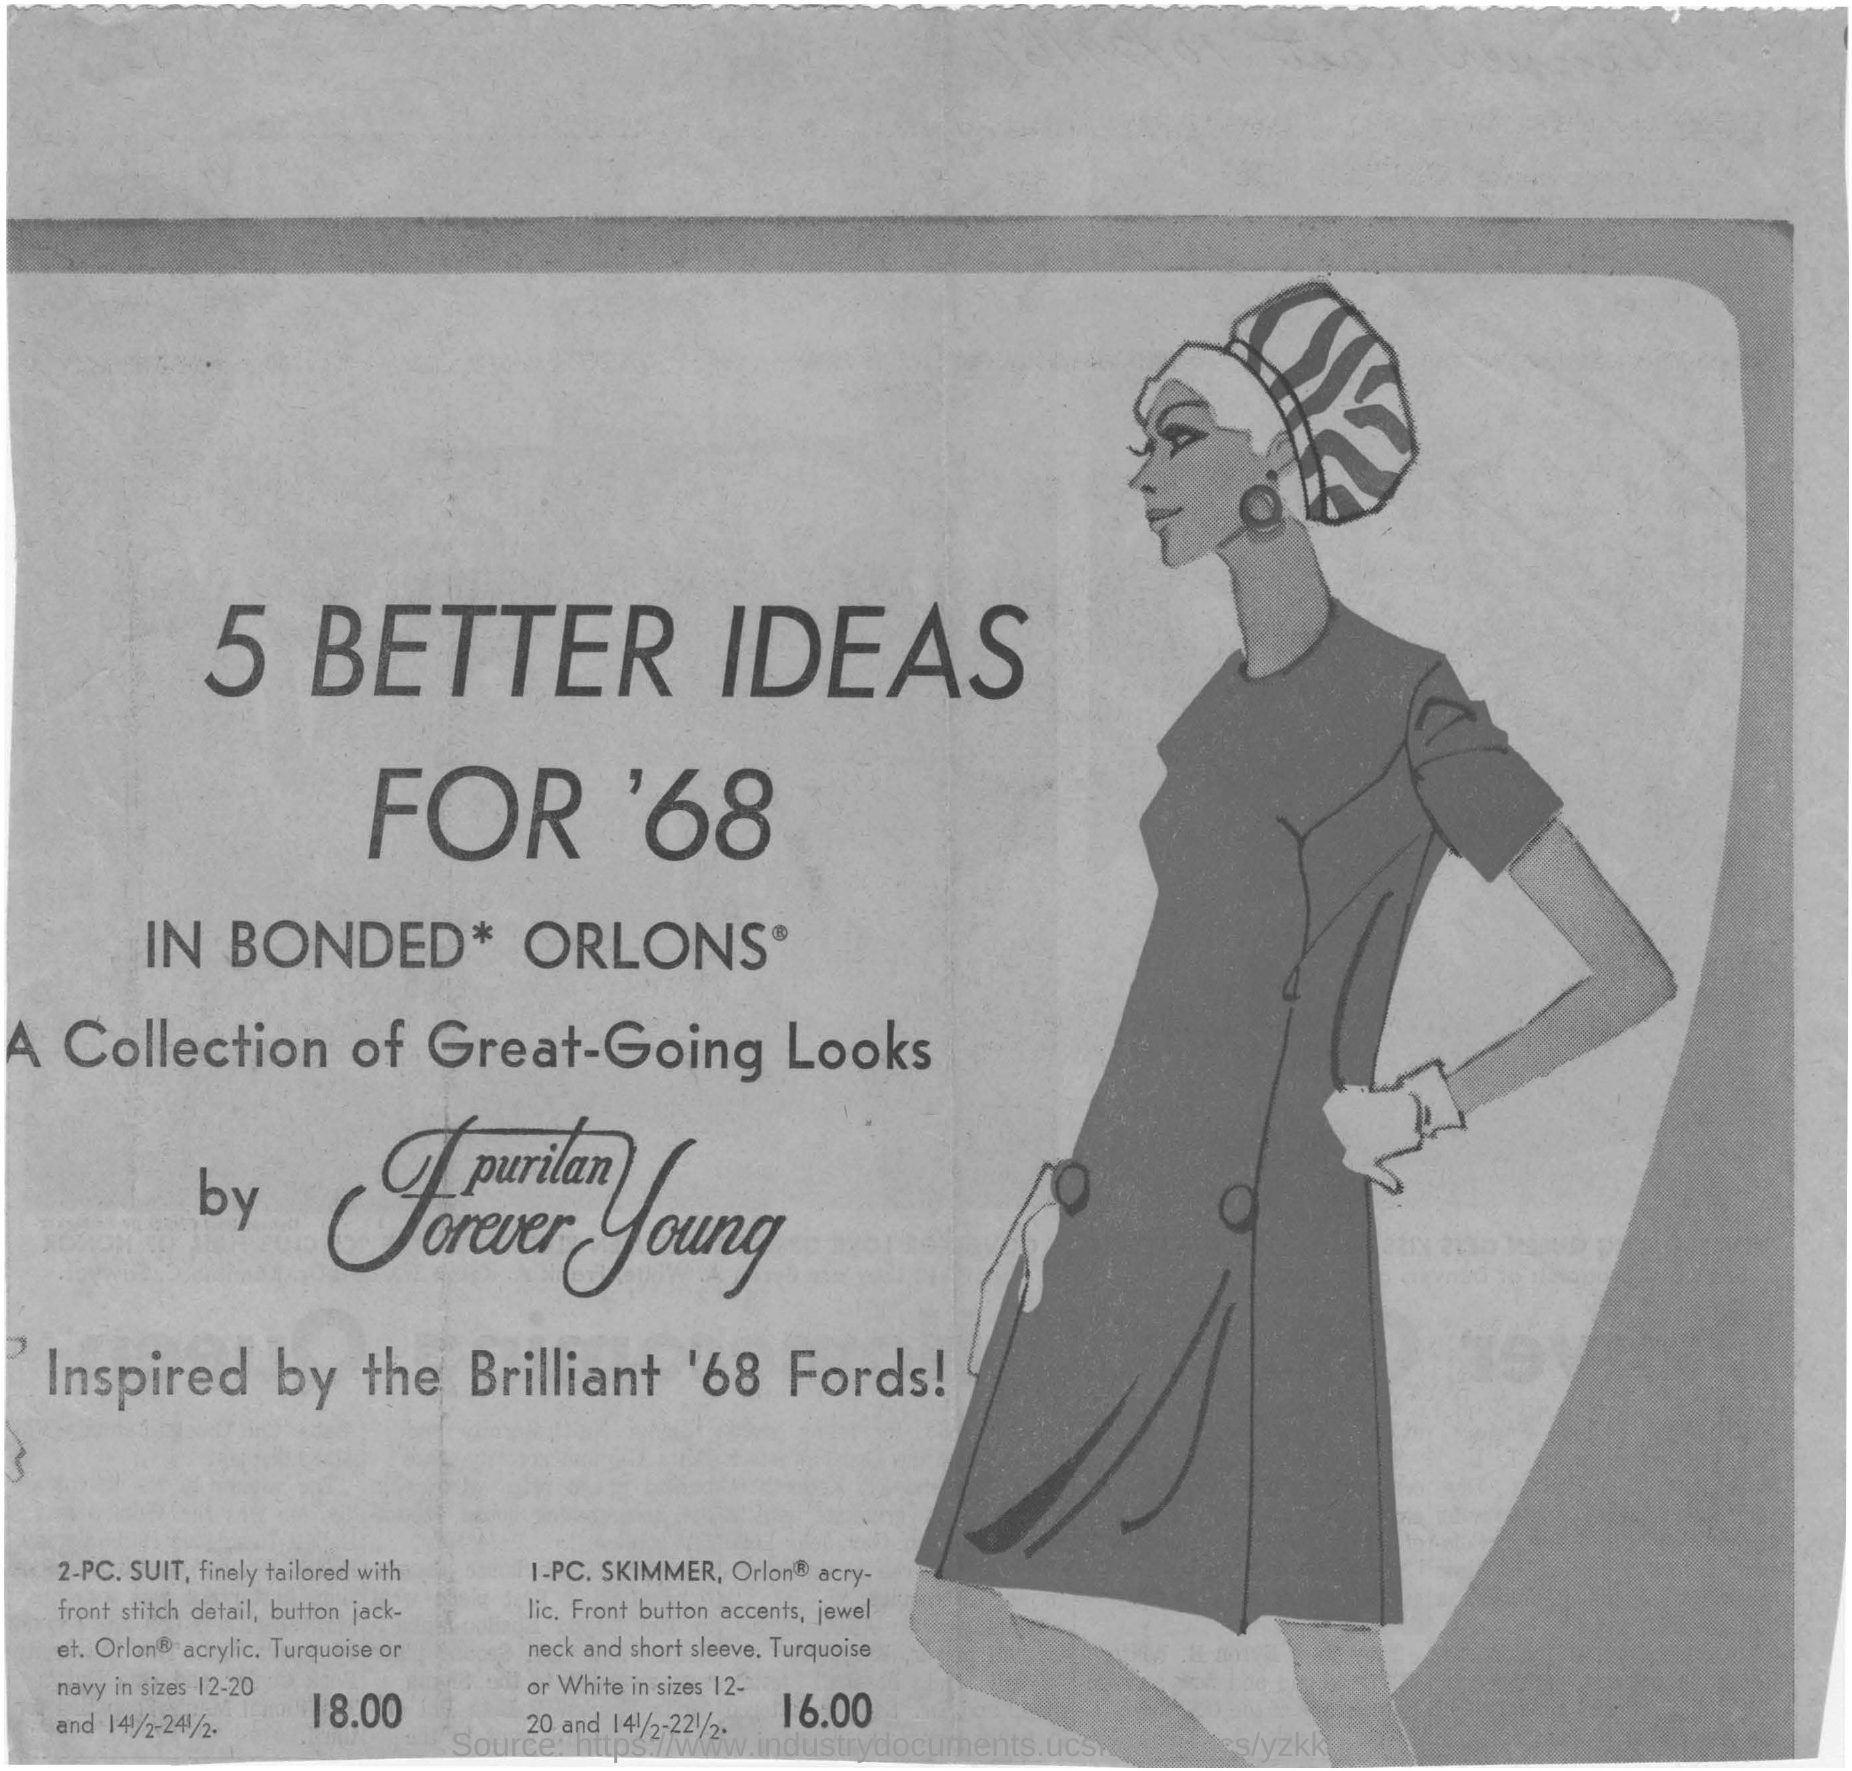Mention a couple of crucial points in this snapshot. This document is inspired by the Brilliant '68 Fords. The sizes of Turquoise or Navy are 12-20 and 141/2-241/2... Five innovative concepts were proposed for the year 1968, including increased personal freedom and technological advancements. 